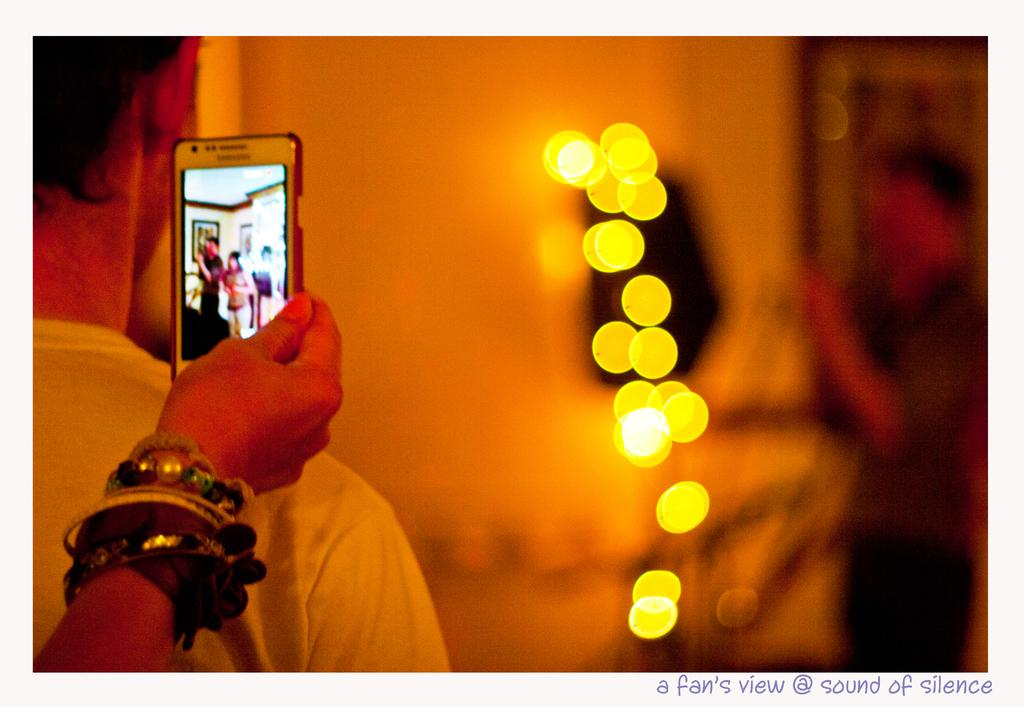How many people are in the image? There are two persons in the image. What is one person doing with their hand? One person is holding a mobile. Can you describe the background of the image? The background of the image is blurred. Is there any additional information or marking on the image? Yes, there is a watermark on the image. Can you tell me what type of doctor is present in the image? There is no doctor present in the image; it features two persons and a mobile. What arithmetic problem can be solved using the numbers in the image? There are no numbers present in the image, so no arithmetic problem can be solved using the numbers in the image. 